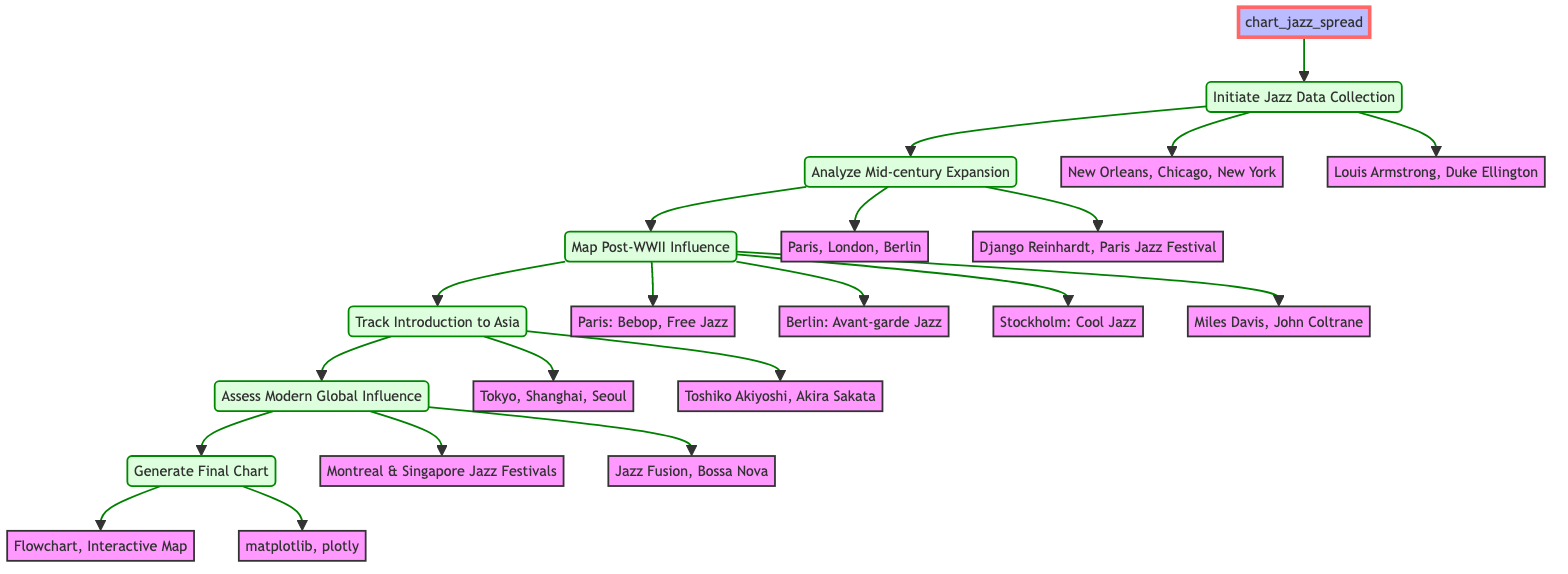What's the function name in the diagram? The function is labeled at the top of the flowchart as "chart_jazz_spread."
Answer: chart_jazz_spread How many steps are there in the function? The flowchart lists six steps leading from the function to the final chart, making a total of six distinct steps.
Answer: 6 What are the key figures in the "Initiate Jazz Data Collection" step? The nodes branching from this step show "Louis Armstrong" and "Duke Ellington" as the key figures identified in jazz's early influence.
Answer: Louis Armstrong, Duke Ellington Which cities are destinations during the "Track Introduction to Asia" step? The diagram outlines three cities linked to this step: "Tokyo," "Shanghai," and "Seoul."
Answer: Tokyo, Shanghai, Seoul What are the important albums listed in the "Map Post-WWII Influence" step? This step mentions two important jazz albums: "Miles Davis' 'Kind of Blue'" and "John Coltrane's 'A Love Supreme.'"
Answer: Miles Davis' 'Kind of Blue', John Coltrane's 'A Love Supreme' Which genre is associated with Stockholm in the "Map Post-WWII Influence" step? The specific node for Stockholm indicates the genre associated with it is "Cool Jazz."
Answer: Cool Jazz What is the output format listed in the "Generate Final Chart" step? The flowchart specifies two output formats: "flowchart" and "interactive_map."
Answer: flowchart, interactive_map Name one notable figure mentioned in the "Track Introduction to Asia" step. The flowchart highlights "Toshiko Akiyoshi" and "Akira Sakata" as notable figures linked to jazz in Asia.
Answer: Toshiko Akiyoshi What is the relationship between "Analyze Mid-century Expansion" and "Map Post-WWII Influence"? "Analyze Mid-century Expansion" leads directly to "Map Post-WWII Influence," indicating a progression in the historical analysis of jazz's geographical spread.
Answer: Directly connected What tools are used in the final chart generation? The flowchart specifies that "matplotlib" and "plotly" are the tools used for generating the final chart.
Answer: matplotlib, plotly 